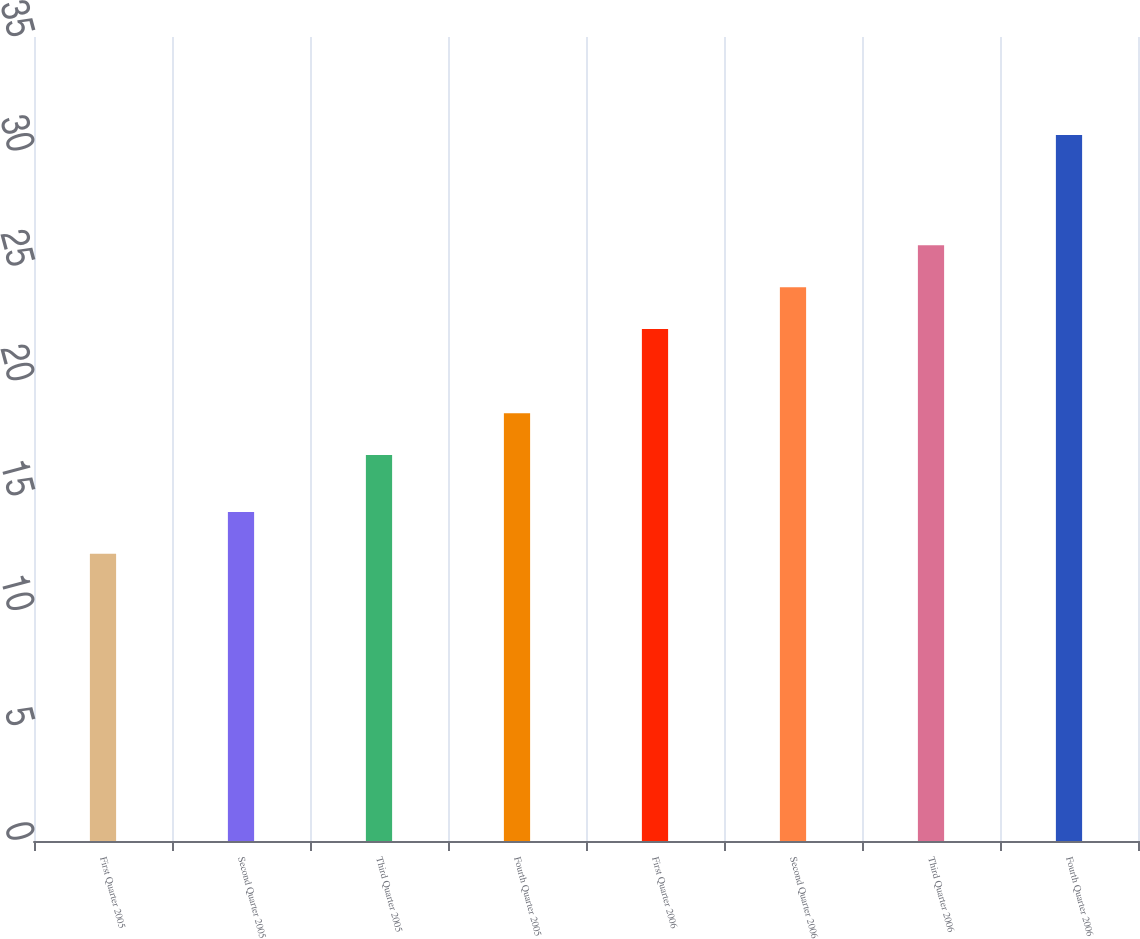Convert chart to OTSL. <chart><loc_0><loc_0><loc_500><loc_500><bar_chart><fcel>First Quarter 2005<fcel>Second Quarter 2005<fcel>Third Quarter 2005<fcel>Fourth Quarter 2005<fcel>First Quarter 2006<fcel>Second Quarter 2006<fcel>Third Quarter 2006<fcel>Fourth Quarter 2006<nl><fcel>12.5<fcel>14.32<fcel>16.8<fcel>18.62<fcel>22.29<fcel>24.11<fcel>25.93<fcel>30.73<nl></chart> 